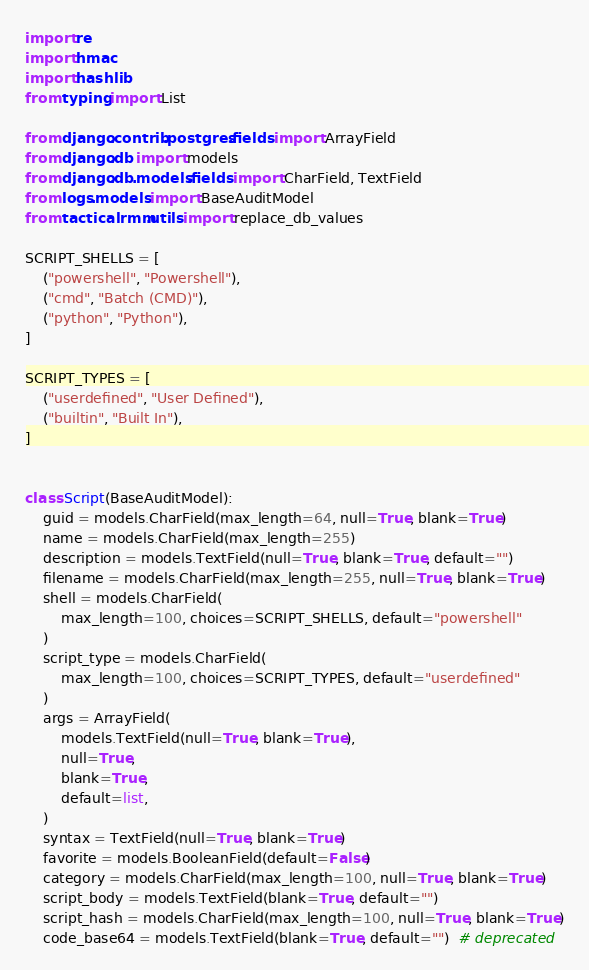<code> <loc_0><loc_0><loc_500><loc_500><_Python_>import re
import hmac
import hashlib
from typing import List

from django.contrib.postgres.fields import ArrayField
from django.db import models
from django.db.models.fields import CharField, TextField
from logs.models import BaseAuditModel
from tacticalrmm.utils import replace_db_values

SCRIPT_SHELLS = [
    ("powershell", "Powershell"),
    ("cmd", "Batch (CMD)"),
    ("python", "Python"),
]

SCRIPT_TYPES = [
    ("userdefined", "User Defined"),
    ("builtin", "Built In"),
]


class Script(BaseAuditModel):
    guid = models.CharField(max_length=64, null=True, blank=True)
    name = models.CharField(max_length=255)
    description = models.TextField(null=True, blank=True, default="")
    filename = models.CharField(max_length=255, null=True, blank=True)
    shell = models.CharField(
        max_length=100, choices=SCRIPT_SHELLS, default="powershell"
    )
    script_type = models.CharField(
        max_length=100, choices=SCRIPT_TYPES, default="userdefined"
    )
    args = ArrayField(
        models.TextField(null=True, blank=True),
        null=True,
        blank=True,
        default=list,
    )
    syntax = TextField(null=True, blank=True)
    favorite = models.BooleanField(default=False)
    category = models.CharField(max_length=100, null=True, blank=True)
    script_body = models.TextField(blank=True, default="")
    script_hash = models.CharField(max_length=100, null=True, blank=True)
    code_base64 = models.TextField(blank=True, default="")  # deprecated</code> 